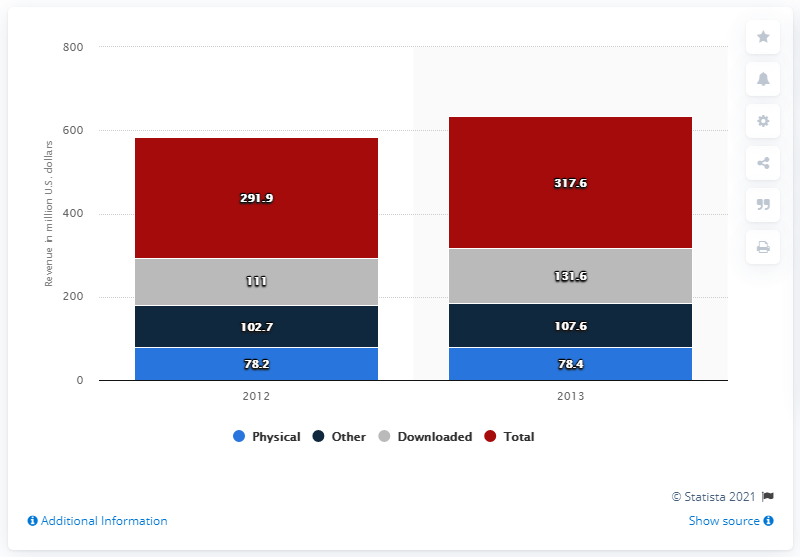Outline some significant characteristics in this image. In 2013, the revenue generated from downloaded adult audiobooks was 131.6 million dollars. 